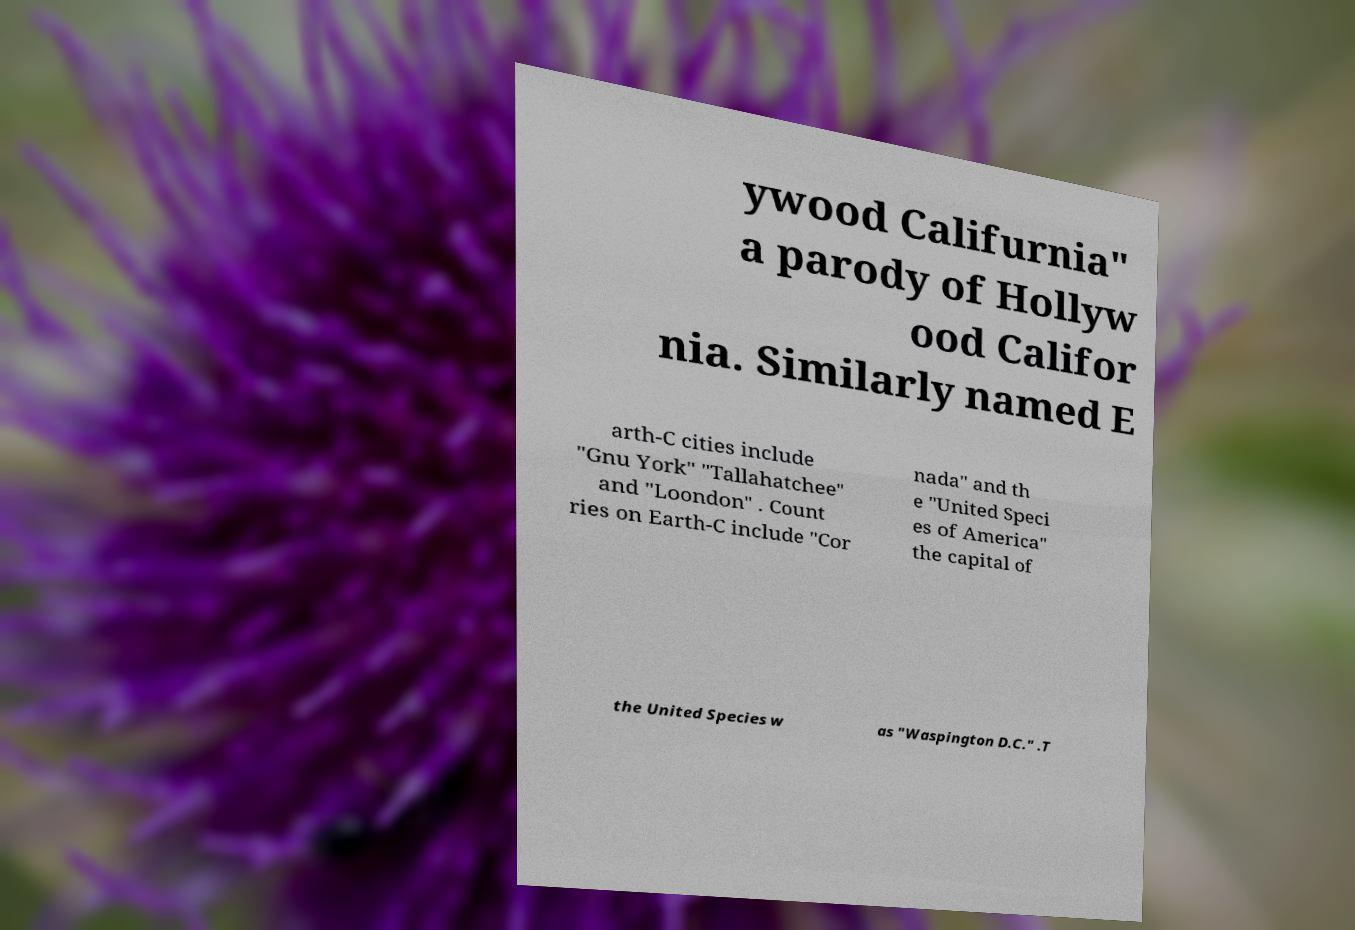Please read and relay the text visible in this image. What does it say? ywood Califurnia" a parody of Hollyw ood Califor nia. Similarly named E arth-C cities include "Gnu York" "Tallahatchee" and "Loondon" . Count ries on Earth-C include "Cor nada" and th e "United Speci es of America" the capital of the United Species w as "Waspington D.C." .T 